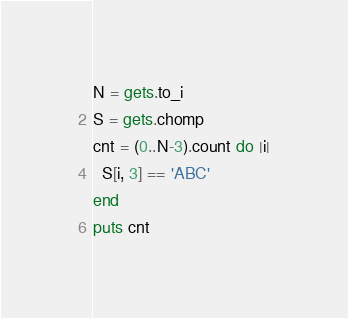<code> <loc_0><loc_0><loc_500><loc_500><_Ruby_>N = gets.to_i
S = gets.chomp
cnt = (0..N-3).count do |i|
  S[i, 3] == 'ABC'
end
puts cnt</code> 